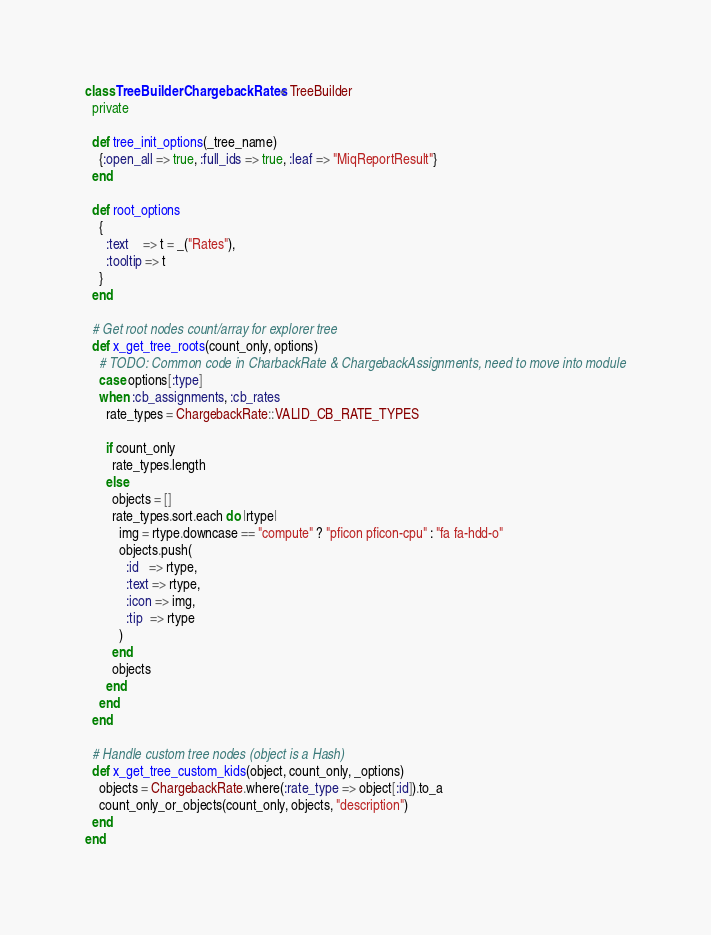Convert code to text. <code><loc_0><loc_0><loc_500><loc_500><_Ruby_>class TreeBuilderChargebackRates < TreeBuilder
  private

  def tree_init_options(_tree_name)
    {:open_all => true, :full_ids => true, :leaf => "MiqReportResult"}
  end

  def root_options
    {
      :text    => t = _("Rates"),
      :tooltip => t
    }
  end

  # Get root nodes count/array for explorer tree
  def x_get_tree_roots(count_only, options)
    # TODO: Common code in CharbackRate & ChargebackAssignments, need to move into module
    case options[:type]
    when :cb_assignments, :cb_rates
      rate_types = ChargebackRate::VALID_CB_RATE_TYPES

      if count_only
        rate_types.length
      else
        objects = []
        rate_types.sort.each do |rtype|
          img = rtype.downcase == "compute" ? "pficon pficon-cpu" : "fa fa-hdd-o"
          objects.push(
            :id   => rtype,
            :text => rtype,
            :icon => img,
            :tip  => rtype
          )
        end
        objects
      end
    end
  end

  # Handle custom tree nodes (object is a Hash)
  def x_get_tree_custom_kids(object, count_only, _options)
    objects = ChargebackRate.where(:rate_type => object[:id]).to_a
    count_only_or_objects(count_only, objects, "description")
  end
end
</code> 